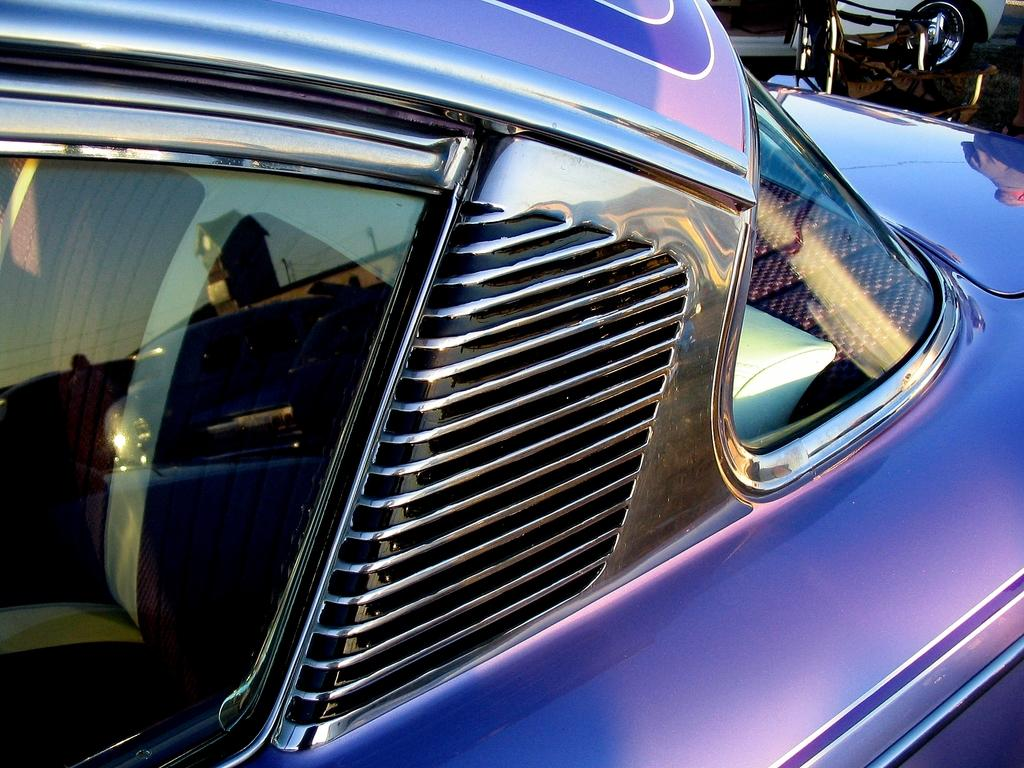What is the main subject of the image? There is a vehicle in the image. How is the vehicle depicted in the image? The vehicle appears to be truncated. What can be seen in the reflection on the glass of the vehicle? There is a reflection of a building on the glass of the vehicle. What part of the natural environment is visible in the reflection on the glass of the vehicle? The sky is visible in the reflection on the glass of the vehicle. What type of frog can be seen playing music in the image? There is no frog or music present in the image; it features a vehicle with a reflection of a building and the sky. 